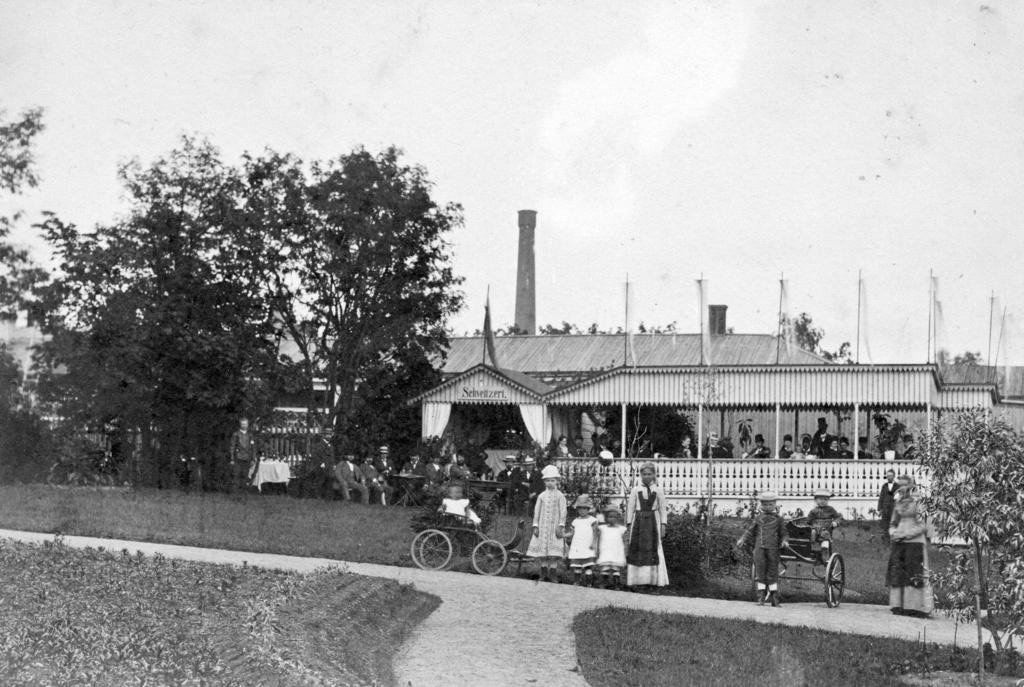Can you describe this image briefly? This is a black and white image. At the bottom there are few children standing on the road and also there are few vehicles. On both side of the road I can see the grass and some plants. In the background there is a building, trees and few people sitting in the garden. At the top of the image I can see the sky. 